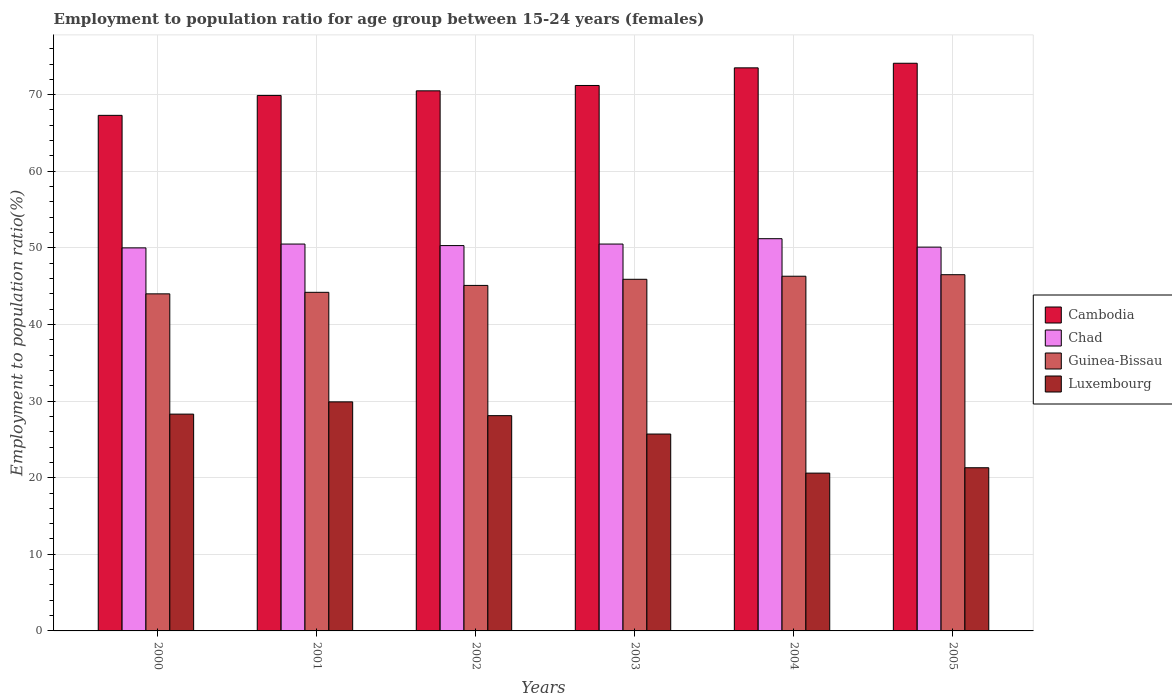How many bars are there on the 5th tick from the left?
Give a very brief answer. 4. How many bars are there on the 5th tick from the right?
Provide a short and direct response. 4. In how many cases, is the number of bars for a given year not equal to the number of legend labels?
Give a very brief answer. 0. What is the employment to population ratio in Chad in 2003?
Your answer should be very brief. 50.5. Across all years, what is the maximum employment to population ratio in Chad?
Your answer should be very brief. 51.2. Across all years, what is the minimum employment to population ratio in Luxembourg?
Provide a succinct answer. 20.6. What is the total employment to population ratio in Luxembourg in the graph?
Keep it short and to the point. 153.9. What is the difference between the employment to population ratio in Guinea-Bissau in 2000 and that in 2002?
Your response must be concise. -1.1. What is the difference between the employment to population ratio in Guinea-Bissau in 2005 and the employment to population ratio in Cambodia in 2004?
Give a very brief answer. -27. What is the average employment to population ratio in Chad per year?
Keep it short and to the point. 50.43. In the year 2003, what is the difference between the employment to population ratio in Chad and employment to population ratio in Cambodia?
Offer a very short reply. -20.7. What is the ratio of the employment to population ratio in Guinea-Bissau in 2002 to that in 2004?
Provide a succinct answer. 0.97. Is the employment to population ratio in Chad in 2002 less than that in 2003?
Keep it short and to the point. Yes. Is the difference between the employment to population ratio in Chad in 2003 and 2005 greater than the difference between the employment to population ratio in Cambodia in 2003 and 2005?
Provide a short and direct response. Yes. What is the difference between the highest and the second highest employment to population ratio in Luxembourg?
Give a very brief answer. 1.6. What is the difference between the highest and the lowest employment to population ratio in Luxembourg?
Offer a terse response. 9.3. Is it the case that in every year, the sum of the employment to population ratio in Chad and employment to population ratio in Cambodia is greater than the sum of employment to population ratio in Luxembourg and employment to population ratio in Guinea-Bissau?
Your response must be concise. No. What does the 1st bar from the left in 2003 represents?
Keep it short and to the point. Cambodia. What does the 4th bar from the right in 2005 represents?
Give a very brief answer. Cambodia. Is it the case that in every year, the sum of the employment to population ratio in Luxembourg and employment to population ratio in Guinea-Bissau is greater than the employment to population ratio in Chad?
Ensure brevity in your answer.  Yes. How many bars are there?
Provide a succinct answer. 24. Does the graph contain any zero values?
Offer a very short reply. No. Where does the legend appear in the graph?
Your answer should be very brief. Center right. How many legend labels are there?
Your response must be concise. 4. How are the legend labels stacked?
Provide a succinct answer. Vertical. What is the title of the graph?
Make the answer very short. Employment to population ratio for age group between 15-24 years (females). Does "Northern Mariana Islands" appear as one of the legend labels in the graph?
Keep it short and to the point. No. What is the label or title of the X-axis?
Your answer should be very brief. Years. What is the Employment to population ratio(%) in Cambodia in 2000?
Provide a short and direct response. 67.3. What is the Employment to population ratio(%) of Luxembourg in 2000?
Give a very brief answer. 28.3. What is the Employment to population ratio(%) of Cambodia in 2001?
Provide a short and direct response. 69.9. What is the Employment to population ratio(%) of Chad in 2001?
Offer a very short reply. 50.5. What is the Employment to population ratio(%) of Guinea-Bissau in 2001?
Offer a terse response. 44.2. What is the Employment to population ratio(%) of Luxembourg in 2001?
Your answer should be very brief. 29.9. What is the Employment to population ratio(%) in Cambodia in 2002?
Ensure brevity in your answer.  70.5. What is the Employment to population ratio(%) of Chad in 2002?
Provide a succinct answer. 50.3. What is the Employment to population ratio(%) in Guinea-Bissau in 2002?
Your response must be concise. 45.1. What is the Employment to population ratio(%) of Luxembourg in 2002?
Provide a short and direct response. 28.1. What is the Employment to population ratio(%) in Cambodia in 2003?
Make the answer very short. 71.2. What is the Employment to population ratio(%) in Chad in 2003?
Offer a terse response. 50.5. What is the Employment to population ratio(%) in Guinea-Bissau in 2003?
Keep it short and to the point. 45.9. What is the Employment to population ratio(%) of Luxembourg in 2003?
Offer a very short reply. 25.7. What is the Employment to population ratio(%) in Cambodia in 2004?
Offer a very short reply. 73.5. What is the Employment to population ratio(%) of Chad in 2004?
Offer a very short reply. 51.2. What is the Employment to population ratio(%) of Guinea-Bissau in 2004?
Your answer should be compact. 46.3. What is the Employment to population ratio(%) in Luxembourg in 2004?
Keep it short and to the point. 20.6. What is the Employment to population ratio(%) in Cambodia in 2005?
Ensure brevity in your answer.  74.1. What is the Employment to population ratio(%) of Chad in 2005?
Ensure brevity in your answer.  50.1. What is the Employment to population ratio(%) of Guinea-Bissau in 2005?
Your answer should be compact. 46.5. What is the Employment to population ratio(%) of Luxembourg in 2005?
Provide a succinct answer. 21.3. Across all years, what is the maximum Employment to population ratio(%) of Cambodia?
Your response must be concise. 74.1. Across all years, what is the maximum Employment to population ratio(%) in Chad?
Offer a very short reply. 51.2. Across all years, what is the maximum Employment to population ratio(%) in Guinea-Bissau?
Keep it short and to the point. 46.5. Across all years, what is the maximum Employment to population ratio(%) in Luxembourg?
Offer a very short reply. 29.9. Across all years, what is the minimum Employment to population ratio(%) in Cambodia?
Make the answer very short. 67.3. Across all years, what is the minimum Employment to population ratio(%) of Luxembourg?
Your answer should be compact. 20.6. What is the total Employment to population ratio(%) of Cambodia in the graph?
Your answer should be very brief. 426.5. What is the total Employment to population ratio(%) of Chad in the graph?
Your answer should be compact. 302.6. What is the total Employment to population ratio(%) of Guinea-Bissau in the graph?
Ensure brevity in your answer.  272. What is the total Employment to population ratio(%) of Luxembourg in the graph?
Your answer should be very brief. 153.9. What is the difference between the Employment to population ratio(%) in Cambodia in 2000 and that in 2002?
Offer a very short reply. -3.2. What is the difference between the Employment to population ratio(%) of Luxembourg in 2000 and that in 2002?
Offer a very short reply. 0.2. What is the difference between the Employment to population ratio(%) in Luxembourg in 2000 and that in 2003?
Provide a short and direct response. 2.6. What is the difference between the Employment to population ratio(%) in Chad in 2000 and that in 2004?
Offer a very short reply. -1.2. What is the difference between the Employment to population ratio(%) in Guinea-Bissau in 2000 and that in 2004?
Give a very brief answer. -2.3. What is the difference between the Employment to population ratio(%) of Guinea-Bissau in 2000 and that in 2005?
Keep it short and to the point. -2.5. What is the difference between the Employment to population ratio(%) of Cambodia in 2001 and that in 2002?
Ensure brevity in your answer.  -0.6. What is the difference between the Employment to population ratio(%) in Cambodia in 2001 and that in 2003?
Give a very brief answer. -1.3. What is the difference between the Employment to population ratio(%) in Chad in 2001 and that in 2003?
Your answer should be very brief. 0. What is the difference between the Employment to population ratio(%) of Guinea-Bissau in 2001 and that in 2003?
Your response must be concise. -1.7. What is the difference between the Employment to population ratio(%) in Luxembourg in 2001 and that in 2003?
Keep it short and to the point. 4.2. What is the difference between the Employment to population ratio(%) of Cambodia in 2001 and that in 2004?
Make the answer very short. -3.6. What is the difference between the Employment to population ratio(%) in Chad in 2001 and that in 2004?
Make the answer very short. -0.7. What is the difference between the Employment to population ratio(%) of Luxembourg in 2001 and that in 2004?
Your response must be concise. 9.3. What is the difference between the Employment to population ratio(%) in Cambodia in 2001 and that in 2005?
Offer a very short reply. -4.2. What is the difference between the Employment to population ratio(%) of Chad in 2001 and that in 2005?
Your answer should be compact. 0.4. What is the difference between the Employment to population ratio(%) of Guinea-Bissau in 2001 and that in 2005?
Offer a terse response. -2.3. What is the difference between the Employment to population ratio(%) of Luxembourg in 2002 and that in 2003?
Your response must be concise. 2.4. What is the difference between the Employment to population ratio(%) of Cambodia in 2002 and that in 2004?
Offer a very short reply. -3. What is the difference between the Employment to population ratio(%) in Chad in 2002 and that in 2004?
Make the answer very short. -0.9. What is the difference between the Employment to population ratio(%) of Luxembourg in 2002 and that in 2004?
Offer a very short reply. 7.5. What is the difference between the Employment to population ratio(%) of Chad in 2002 and that in 2005?
Provide a short and direct response. 0.2. What is the difference between the Employment to population ratio(%) of Guinea-Bissau in 2002 and that in 2005?
Keep it short and to the point. -1.4. What is the difference between the Employment to population ratio(%) of Luxembourg in 2002 and that in 2005?
Your answer should be compact. 6.8. What is the difference between the Employment to population ratio(%) of Cambodia in 2003 and that in 2004?
Your answer should be very brief. -2.3. What is the difference between the Employment to population ratio(%) in Cambodia in 2003 and that in 2005?
Ensure brevity in your answer.  -2.9. What is the difference between the Employment to population ratio(%) in Chad in 2003 and that in 2005?
Give a very brief answer. 0.4. What is the difference between the Employment to population ratio(%) of Cambodia in 2004 and that in 2005?
Keep it short and to the point. -0.6. What is the difference between the Employment to population ratio(%) in Chad in 2004 and that in 2005?
Make the answer very short. 1.1. What is the difference between the Employment to population ratio(%) in Luxembourg in 2004 and that in 2005?
Your response must be concise. -0.7. What is the difference between the Employment to population ratio(%) of Cambodia in 2000 and the Employment to population ratio(%) of Chad in 2001?
Your answer should be very brief. 16.8. What is the difference between the Employment to population ratio(%) of Cambodia in 2000 and the Employment to population ratio(%) of Guinea-Bissau in 2001?
Your answer should be compact. 23.1. What is the difference between the Employment to population ratio(%) of Cambodia in 2000 and the Employment to population ratio(%) of Luxembourg in 2001?
Your response must be concise. 37.4. What is the difference between the Employment to population ratio(%) of Chad in 2000 and the Employment to population ratio(%) of Luxembourg in 2001?
Give a very brief answer. 20.1. What is the difference between the Employment to population ratio(%) of Guinea-Bissau in 2000 and the Employment to population ratio(%) of Luxembourg in 2001?
Your answer should be very brief. 14.1. What is the difference between the Employment to population ratio(%) in Cambodia in 2000 and the Employment to population ratio(%) in Chad in 2002?
Your response must be concise. 17. What is the difference between the Employment to population ratio(%) in Cambodia in 2000 and the Employment to population ratio(%) in Luxembourg in 2002?
Keep it short and to the point. 39.2. What is the difference between the Employment to population ratio(%) in Chad in 2000 and the Employment to population ratio(%) in Luxembourg in 2002?
Offer a very short reply. 21.9. What is the difference between the Employment to population ratio(%) of Guinea-Bissau in 2000 and the Employment to population ratio(%) of Luxembourg in 2002?
Give a very brief answer. 15.9. What is the difference between the Employment to population ratio(%) of Cambodia in 2000 and the Employment to population ratio(%) of Chad in 2003?
Your answer should be very brief. 16.8. What is the difference between the Employment to population ratio(%) in Cambodia in 2000 and the Employment to population ratio(%) in Guinea-Bissau in 2003?
Your response must be concise. 21.4. What is the difference between the Employment to population ratio(%) of Cambodia in 2000 and the Employment to population ratio(%) of Luxembourg in 2003?
Your response must be concise. 41.6. What is the difference between the Employment to population ratio(%) in Chad in 2000 and the Employment to population ratio(%) in Luxembourg in 2003?
Provide a succinct answer. 24.3. What is the difference between the Employment to population ratio(%) in Cambodia in 2000 and the Employment to population ratio(%) in Guinea-Bissau in 2004?
Provide a succinct answer. 21. What is the difference between the Employment to population ratio(%) in Cambodia in 2000 and the Employment to population ratio(%) in Luxembourg in 2004?
Provide a short and direct response. 46.7. What is the difference between the Employment to population ratio(%) in Chad in 2000 and the Employment to population ratio(%) in Guinea-Bissau in 2004?
Ensure brevity in your answer.  3.7. What is the difference between the Employment to population ratio(%) of Chad in 2000 and the Employment to population ratio(%) of Luxembourg in 2004?
Your answer should be compact. 29.4. What is the difference between the Employment to population ratio(%) in Guinea-Bissau in 2000 and the Employment to population ratio(%) in Luxembourg in 2004?
Keep it short and to the point. 23.4. What is the difference between the Employment to population ratio(%) of Cambodia in 2000 and the Employment to population ratio(%) of Guinea-Bissau in 2005?
Provide a short and direct response. 20.8. What is the difference between the Employment to population ratio(%) of Chad in 2000 and the Employment to population ratio(%) of Luxembourg in 2005?
Ensure brevity in your answer.  28.7. What is the difference between the Employment to population ratio(%) in Guinea-Bissau in 2000 and the Employment to population ratio(%) in Luxembourg in 2005?
Provide a short and direct response. 22.7. What is the difference between the Employment to population ratio(%) of Cambodia in 2001 and the Employment to population ratio(%) of Chad in 2002?
Your response must be concise. 19.6. What is the difference between the Employment to population ratio(%) in Cambodia in 2001 and the Employment to population ratio(%) in Guinea-Bissau in 2002?
Ensure brevity in your answer.  24.8. What is the difference between the Employment to population ratio(%) of Cambodia in 2001 and the Employment to population ratio(%) of Luxembourg in 2002?
Provide a succinct answer. 41.8. What is the difference between the Employment to population ratio(%) in Chad in 2001 and the Employment to population ratio(%) in Luxembourg in 2002?
Make the answer very short. 22.4. What is the difference between the Employment to population ratio(%) in Guinea-Bissau in 2001 and the Employment to population ratio(%) in Luxembourg in 2002?
Ensure brevity in your answer.  16.1. What is the difference between the Employment to population ratio(%) of Cambodia in 2001 and the Employment to population ratio(%) of Chad in 2003?
Keep it short and to the point. 19.4. What is the difference between the Employment to population ratio(%) in Cambodia in 2001 and the Employment to population ratio(%) in Guinea-Bissau in 2003?
Offer a terse response. 24. What is the difference between the Employment to population ratio(%) of Cambodia in 2001 and the Employment to population ratio(%) of Luxembourg in 2003?
Give a very brief answer. 44.2. What is the difference between the Employment to population ratio(%) in Chad in 2001 and the Employment to population ratio(%) in Luxembourg in 2003?
Your answer should be compact. 24.8. What is the difference between the Employment to population ratio(%) of Guinea-Bissau in 2001 and the Employment to population ratio(%) of Luxembourg in 2003?
Provide a succinct answer. 18.5. What is the difference between the Employment to population ratio(%) in Cambodia in 2001 and the Employment to population ratio(%) in Chad in 2004?
Your response must be concise. 18.7. What is the difference between the Employment to population ratio(%) of Cambodia in 2001 and the Employment to population ratio(%) of Guinea-Bissau in 2004?
Your answer should be very brief. 23.6. What is the difference between the Employment to population ratio(%) in Cambodia in 2001 and the Employment to population ratio(%) in Luxembourg in 2004?
Offer a very short reply. 49.3. What is the difference between the Employment to population ratio(%) of Chad in 2001 and the Employment to population ratio(%) of Guinea-Bissau in 2004?
Your answer should be compact. 4.2. What is the difference between the Employment to population ratio(%) of Chad in 2001 and the Employment to population ratio(%) of Luxembourg in 2004?
Provide a succinct answer. 29.9. What is the difference between the Employment to population ratio(%) of Guinea-Bissau in 2001 and the Employment to population ratio(%) of Luxembourg in 2004?
Provide a short and direct response. 23.6. What is the difference between the Employment to population ratio(%) in Cambodia in 2001 and the Employment to population ratio(%) in Chad in 2005?
Offer a terse response. 19.8. What is the difference between the Employment to population ratio(%) of Cambodia in 2001 and the Employment to population ratio(%) of Guinea-Bissau in 2005?
Provide a short and direct response. 23.4. What is the difference between the Employment to population ratio(%) in Cambodia in 2001 and the Employment to population ratio(%) in Luxembourg in 2005?
Offer a very short reply. 48.6. What is the difference between the Employment to population ratio(%) in Chad in 2001 and the Employment to population ratio(%) in Luxembourg in 2005?
Ensure brevity in your answer.  29.2. What is the difference between the Employment to population ratio(%) of Guinea-Bissau in 2001 and the Employment to population ratio(%) of Luxembourg in 2005?
Your answer should be very brief. 22.9. What is the difference between the Employment to population ratio(%) in Cambodia in 2002 and the Employment to population ratio(%) in Chad in 2003?
Provide a succinct answer. 20. What is the difference between the Employment to population ratio(%) of Cambodia in 2002 and the Employment to population ratio(%) of Guinea-Bissau in 2003?
Your answer should be compact. 24.6. What is the difference between the Employment to population ratio(%) of Cambodia in 2002 and the Employment to population ratio(%) of Luxembourg in 2003?
Offer a terse response. 44.8. What is the difference between the Employment to population ratio(%) of Chad in 2002 and the Employment to population ratio(%) of Luxembourg in 2003?
Your answer should be compact. 24.6. What is the difference between the Employment to population ratio(%) of Cambodia in 2002 and the Employment to population ratio(%) of Chad in 2004?
Your response must be concise. 19.3. What is the difference between the Employment to population ratio(%) of Cambodia in 2002 and the Employment to population ratio(%) of Guinea-Bissau in 2004?
Make the answer very short. 24.2. What is the difference between the Employment to population ratio(%) in Cambodia in 2002 and the Employment to population ratio(%) in Luxembourg in 2004?
Your answer should be very brief. 49.9. What is the difference between the Employment to population ratio(%) of Chad in 2002 and the Employment to population ratio(%) of Guinea-Bissau in 2004?
Your answer should be compact. 4. What is the difference between the Employment to population ratio(%) in Chad in 2002 and the Employment to population ratio(%) in Luxembourg in 2004?
Your response must be concise. 29.7. What is the difference between the Employment to population ratio(%) of Guinea-Bissau in 2002 and the Employment to population ratio(%) of Luxembourg in 2004?
Provide a succinct answer. 24.5. What is the difference between the Employment to population ratio(%) of Cambodia in 2002 and the Employment to population ratio(%) of Chad in 2005?
Your answer should be compact. 20.4. What is the difference between the Employment to population ratio(%) of Cambodia in 2002 and the Employment to population ratio(%) of Luxembourg in 2005?
Provide a short and direct response. 49.2. What is the difference between the Employment to population ratio(%) of Chad in 2002 and the Employment to population ratio(%) of Luxembourg in 2005?
Offer a terse response. 29. What is the difference between the Employment to population ratio(%) in Guinea-Bissau in 2002 and the Employment to population ratio(%) in Luxembourg in 2005?
Make the answer very short. 23.8. What is the difference between the Employment to population ratio(%) in Cambodia in 2003 and the Employment to population ratio(%) in Guinea-Bissau in 2004?
Make the answer very short. 24.9. What is the difference between the Employment to population ratio(%) in Cambodia in 2003 and the Employment to population ratio(%) in Luxembourg in 2004?
Offer a very short reply. 50.6. What is the difference between the Employment to population ratio(%) in Chad in 2003 and the Employment to population ratio(%) in Guinea-Bissau in 2004?
Make the answer very short. 4.2. What is the difference between the Employment to population ratio(%) in Chad in 2003 and the Employment to population ratio(%) in Luxembourg in 2004?
Provide a succinct answer. 29.9. What is the difference between the Employment to population ratio(%) of Guinea-Bissau in 2003 and the Employment to population ratio(%) of Luxembourg in 2004?
Provide a short and direct response. 25.3. What is the difference between the Employment to population ratio(%) in Cambodia in 2003 and the Employment to population ratio(%) in Chad in 2005?
Your answer should be very brief. 21.1. What is the difference between the Employment to population ratio(%) in Cambodia in 2003 and the Employment to population ratio(%) in Guinea-Bissau in 2005?
Ensure brevity in your answer.  24.7. What is the difference between the Employment to population ratio(%) of Cambodia in 2003 and the Employment to population ratio(%) of Luxembourg in 2005?
Your response must be concise. 49.9. What is the difference between the Employment to population ratio(%) in Chad in 2003 and the Employment to population ratio(%) in Luxembourg in 2005?
Your answer should be compact. 29.2. What is the difference between the Employment to population ratio(%) of Guinea-Bissau in 2003 and the Employment to population ratio(%) of Luxembourg in 2005?
Give a very brief answer. 24.6. What is the difference between the Employment to population ratio(%) of Cambodia in 2004 and the Employment to population ratio(%) of Chad in 2005?
Your answer should be very brief. 23.4. What is the difference between the Employment to population ratio(%) of Cambodia in 2004 and the Employment to population ratio(%) of Guinea-Bissau in 2005?
Provide a short and direct response. 27. What is the difference between the Employment to population ratio(%) in Cambodia in 2004 and the Employment to population ratio(%) in Luxembourg in 2005?
Your answer should be compact. 52.2. What is the difference between the Employment to population ratio(%) in Chad in 2004 and the Employment to population ratio(%) in Luxembourg in 2005?
Ensure brevity in your answer.  29.9. What is the difference between the Employment to population ratio(%) of Guinea-Bissau in 2004 and the Employment to population ratio(%) of Luxembourg in 2005?
Offer a terse response. 25. What is the average Employment to population ratio(%) in Cambodia per year?
Offer a very short reply. 71.08. What is the average Employment to population ratio(%) of Chad per year?
Keep it short and to the point. 50.43. What is the average Employment to population ratio(%) of Guinea-Bissau per year?
Your answer should be compact. 45.33. What is the average Employment to population ratio(%) of Luxembourg per year?
Your response must be concise. 25.65. In the year 2000, what is the difference between the Employment to population ratio(%) in Cambodia and Employment to population ratio(%) in Guinea-Bissau?
Ensure brevity in your answer.  23.3. In the year 2000, what is the difference between the Employment to population ratio(%) of Chad and Employment to population ratio(%) of Luxembourg?
Give a very brief answer. 21.7. In the year 2001, what is the difference between the Employment to population ratio(%) of Cambodia and Employment to population ratio(%) of Chad?
Offer a very short reply. 19.4. In the year 2001, what is the difference between the Employment to population ratio(%) in Cambodia and Employment to population ratio(%) in Guinea-Bissau?
Provide a succinct answer. 25.7. In the year 2001, what is the difference between the Employment to population ratio(%) of Cambodia and Employment to population ratio(%) of Luxembourg?
Offer a very short reply. 40. In the year 2001, what is the difference between the Employment to population ratio(%) of Chad and Employment to population ratio(%) of Guinea-Bissau?
Your answer should be very brief. 6.3. In the year 2001, what is the difference between the Employment to population ratio(%) of Chad and Employment to population ratio(%) of Luxembourg?
Ensure brevity in your answer.  20.6. In the year 2002, what is the difference between the Employment to population ratio(%) of Cambodia and Employment to population ratio(%) of Chad?
Give a very brief answer. 20.2. In the year 2002, what is the difference between the Employment to population ratio(%) in Cambodia and Employment to population ratio(%) in Guinea-Bissau?
Keep it short and to the point. 25.4. In the year 2002, what is the difference between the Employment to population ratio(%) of Cambodia and Employment to population ratio(%) of Luxembourg?
Provide a succinct answer. 42.4. In the year 2002, what is the difference between the Employment to population ratio(%) of Chad and Employment to population ratio(%) of Guinea-Bissau?
Provide a succinct answer. 5.2. In the year 2003, what is the difference between the Employment to population ratio(%) in Cambodia and Employment to population ratio(%) in Chad?
Make the answer very short. 20.7. In the year 2003, what is the difference between the Employment to population ratio(%) of Cambodia and Employment to population ratio(%) of Guinea-Bissau?
Offer a very short reply. 25.3. In the year 2003, what is the difference between the Employment to population ratio(%) in Cambodia and Employment to population ratio(%) in Luxembourg?
Offer a very short reply. 45.5. In the year 2003, what is the difference between the Employment to population ratio(%) in Chad and Employment to population ratio(%) in Guinea-Bissau?
Provide a short and direct response. 4.6. In the year 2003, what is the difference between the Employment to population ratio(%) in Chad and Employment to population ratio(%) in Luxembourg?
Make the answer very short. 24.8. In the year 2003, what is the difference between the Employment to population ratio(%) of Guinea-Bissau and Employment to population ratio(%) of Luxembourg?
Offer a very short reply. 20.2. In the year 2004, what is the difference between the Employment to population ratio(%) in Cambodia and Employment to population ratio(%) in Chad?
Your answer should be compact. 22.3. In the year 2004, what is the difference between the Employment to population ratio(%) of Cambodia and Employment to population ratio(%) of Guinea-Bissau?
Give a very brief answer. 27.2. In the year 2004, what is the difference between the Employment to population ratio(%) of Cambodia and Employment to population ratio(%) of Luxembourg?
Your answer should be compact. 52.9. In the year 2004, what is the difference between the Employment to population ratio(%) in Chad and Employment to population ratio(%) in Guinea-Bissau?
Make the answer very short. 4.9. In the year 2004, what is the difference between the Employment to population ratio(%) in Chad and Employment to population ratio(%) in Luxembourg?
Give a very brief answer. 30.6. In the year 2004, what is the difference between the Employment to population ratio(%) in Guinea-Bissau and Employment to population ratio(%) in Luxembourg?
Make the answer very short. 25.7. In the year 2005, what is the difference between the Employment to population ratio(%) in Cambodia and Employment to population ratio(%) in Guinea-Bissau?
Provide a succinct answer. 27.6. In the year 2005, what is the difference between the Employment to population ratio(%) in Cambodia and Employment to population ratio(%) in Luxembourg?
Your answer should be compact. 52.8. In the year 2005, what is the difference between the Employment to population ratio(%) of Chad and Employment to population ratio(%) of Luxembourg?
Your response must be concise. 28.8. In the year 2005, what is the difference between the Employment to population ratio(%) of Guinea-Bissau and Employment to population ratio(%) of Luxembourg?
Your answer should be compact. 25.2. What is the ratio of the Employment to population ratio(%) in Cambodia in 2000 to that in 2001?
Keep it short and to the point. 0.96. What is the ratio of the Employment to population ratio(%) of Chad in 2000 to that in 2001?
Offer a terse response. 0.99. What is the ratio of the Employment to population ratio(%) in Luxembourg in 2000 to that in 2001?
Make the answer very short. 0.95. What is the ratio of the Employment to population ratio(%) of Cambodia in 2000 to that in 2002?
Make the answer very short. 0.95. What is the ratio of the Employment to population ratio(%) of Guinea-Bissau in 2000 to that in 2002?
Offer a very short reply. 0.98. What is the ratio of the Employment to population ratio(%) in Luxembourg in 2000 to that in 2002?
Make the answer very short. 1.01. What is the ratio of the Employment to population ratio(%) in Cambodia in 2000 to that in 2003?
Keep it short and to the point. 0.95. What is the ratio of the Employment to population ratio(%) in Chad in 2000 to that in 2003?
Keep it short and to the point. 0.99. What is the ratio of the Employment to population ratio(%) in Guinea-Bissau in 2000 to that in 2003?
Your answer should be compact. 0.96. What is the ratio of the Employment to population ratio(%) of Luxembourg in 2000 to that in 2003?
Make the answer very short. 1.1. What is the ratio of the Employment to population ratio(%) of Cambodia in 2000 to that in 2004?
Your response must be concise. 0.92. What is the ratio of the Employment to population ratio(%) in Chad in 2000 to that in 2004?
Offer a terse response. 0.98. What is the ratio of the Employment to population ratio(%) in Guinea-Bissau in 2000 to that in 2004?
Provide a short and direct response. 0.95. What is the ratio of the Employment to population ratio(%) in Luxembourg in 2000 to that in 2004?
Give a very brief answer. 1.37. What is the ratio of the Employment to population ratio(%) in Cambodia in 2000 to that in 2005?
Offer a terse response. 0.91. What is the ratio of the Employment to population ratio(%) of Guinea-Bissau in 2000 to that in 2005?
Your answer should be very brief. 0.95. What is the ratio of the Employment to population ratio(%) in Luxembourg in 2000 to that in 2005?
Your answer should be compact. 1.33. What is the ratio of the Employment to population ratio(%) in Cambodia in 2001 to that in 2002?
Provide a short and direct response. 0.99. What is the ratio of the Employment to population ratio(%) in Luxembourg in 2001 to that in 2002?
Offer a very short reply. 1.06. What is the ratio of the Employment to population ratio(%) of Cambodia in 2001 to that in 2003?
Make the answer very short. 0.98. What is the ratio of the Employment to population ratio(%) in Chad in 2001 to that in 2003?
Provide a short and direct response. 1. What is the ratio of the Employment to population ratio(%) of Luxembourg in 2001 to that in 2003?
Offer a terse response. 1.16. What is the ratio of the Employment to population ratio(%) of Cambodia in 2001 to that in 2004?
Offer a terse response. 0.95. What is the ratio of the Employment to population ratio(%) of Chad in 2001 to that in 2004?
Ensure brevity in your answer.  0.99. What is the ratio of the Employment to population ratio(%) in Guinea-Bissau in 2001 to that in 2004?
Your answer should be compact. 0.95. What is the ratio of the Employment to population ratio(%) of Luxembourg in 2001 to that in 2004?
Offer a very short reply. 1.45. What is the ratio of the Employment to population ratio(%) in Cambodia in 2001 to that in 2005?
Keep it short and to the point. 0.94. What is the ratio of the Employment to population ratio(%) of Chad in 2001 to that in 2005?
Your response must be concise. 1.01. What is the ratio of the Employment to population ratio(%) in Guinea-Bissau in 2001 to that in 2005?
Your answer should be very brief. 0.95. What is the ratio of the Employment to population ratio(%) in Luxembourg in 2001 to that in 2005?
Your answer should be very brief. 1.4. What is the ratio of the Employment to population ratio(%) of Cambodia in 2002 to that in 2003?
Ensure brevity in your answer.  0.99. What is the ratio of the Employment to population ratio(%) in Chad in 2002 to that in 2003?
Offer a terse response. 1. What is the ratio of the Employment to population ratio(%) of Guinea-Bissau in 2002 to that in 2003?
Make the answer very short. 0.98. What is the ratio of the Employment to population ratio(%) of Luxembourg in 2002 to that in 2003?
Make the answer very short. 1.09. What is the ratio of the Employment to population ratio(%) in Cambodia in 2002 to that in 2004?
Ensure brevity in your answer.  0.96. What is the ratio of the Employment to population ratio(%) of Chad in 2002 to that in 2004?
Offer a terse response. 0.98. What is the ratio of the Employment to population ratio(%) in Guinea-Bissau in 2002 to that in 2004?
Provide a succinct answer. 0.97. What is the ratio of the Employment to population ratio(%) of Luxembourg in 2002 to that in 2004?
Offer a very short reply. 1.36. What is the ratio of the Employment to population ratio(%) of Cambodia in 2002 to that in 2005?
Your answer should be very brief. 0.95. What is the ratio of the Employment to population ratio(%) in Guinea-Bissau in 2002 to that in 2005?
Keep it short and to the point. 0.97. What is the ratio of the Employment to population ratio(%) in Luxembourg in 2002 to that in 2005?
Offer a terse response. 1.32. What is the ratio of the Employment to population ratio(%) in Cambodia in 2003 to that in 2004?
Give a very brief answer. 0.97. What is the ratio of the Employment to population ratio(%) of Chad in 2003 to that in 2004?
Give a very brief answer. 0.99. What is the ratio of the Employment to population ratio(%) of Guinea-Bissau in 2003 to that in 2004?
Offer a very short reply. 0.99. What is the ratio of the Employment to population ratio(%) of Luxembourg in 2003 to that in 2004?
Your answer should be compact. 1.25. What is the ratio of the Employment to population ratio(%) in Cambodia in 2003 to that in 2005?
Provide a short and direct response. 0.96. What is the ratio of the Employment to population ratio(%) of Chad in 2003 to that in 2005?
Your answer should be very brief. 1.01. What is the ratio of the Employment to population ratio(%) of Guinea-Bissau in 2003 to that in 2005?
Make the answer very short. 0.99. What is the ratio of the Employment to population ratio(%) of Luxembourg in 2003 to that in 2005?
Your answer should be very brief. 1.21. What is the ratio of the Employment to population ratio(%) of Chad in 2004 to that in 2005?
Your response must be concise. 1.02. What is the ratio of the Employment to population ratio(%) in Guinea-Bissau in 2004 to that in 2005?
Ensure brevity in your answer.  1. What is the ratio of the Employment to population ratio(%) of Luxembourg in 2004 to that in 2005?
Provide a succinct answer. 0.97. What is the difference between the highest and the second highest Employment to population ratio(%) of Chad?
Your answer should be very brief. 0.7. What is the difference between the highest and the second highest Employment to population ratio(%) of Guinea-Bissau?
Make the answer very short. 0.2. What is the difference between the highest and the lowest Employment to population ratio(%) in Cambodia?
Make the answer very short. 6.8. What is the difference between the highest and the lowest Employment to population ratio(%) of Guinea-Bissau?
Provide a succinct answer. 2.5. 